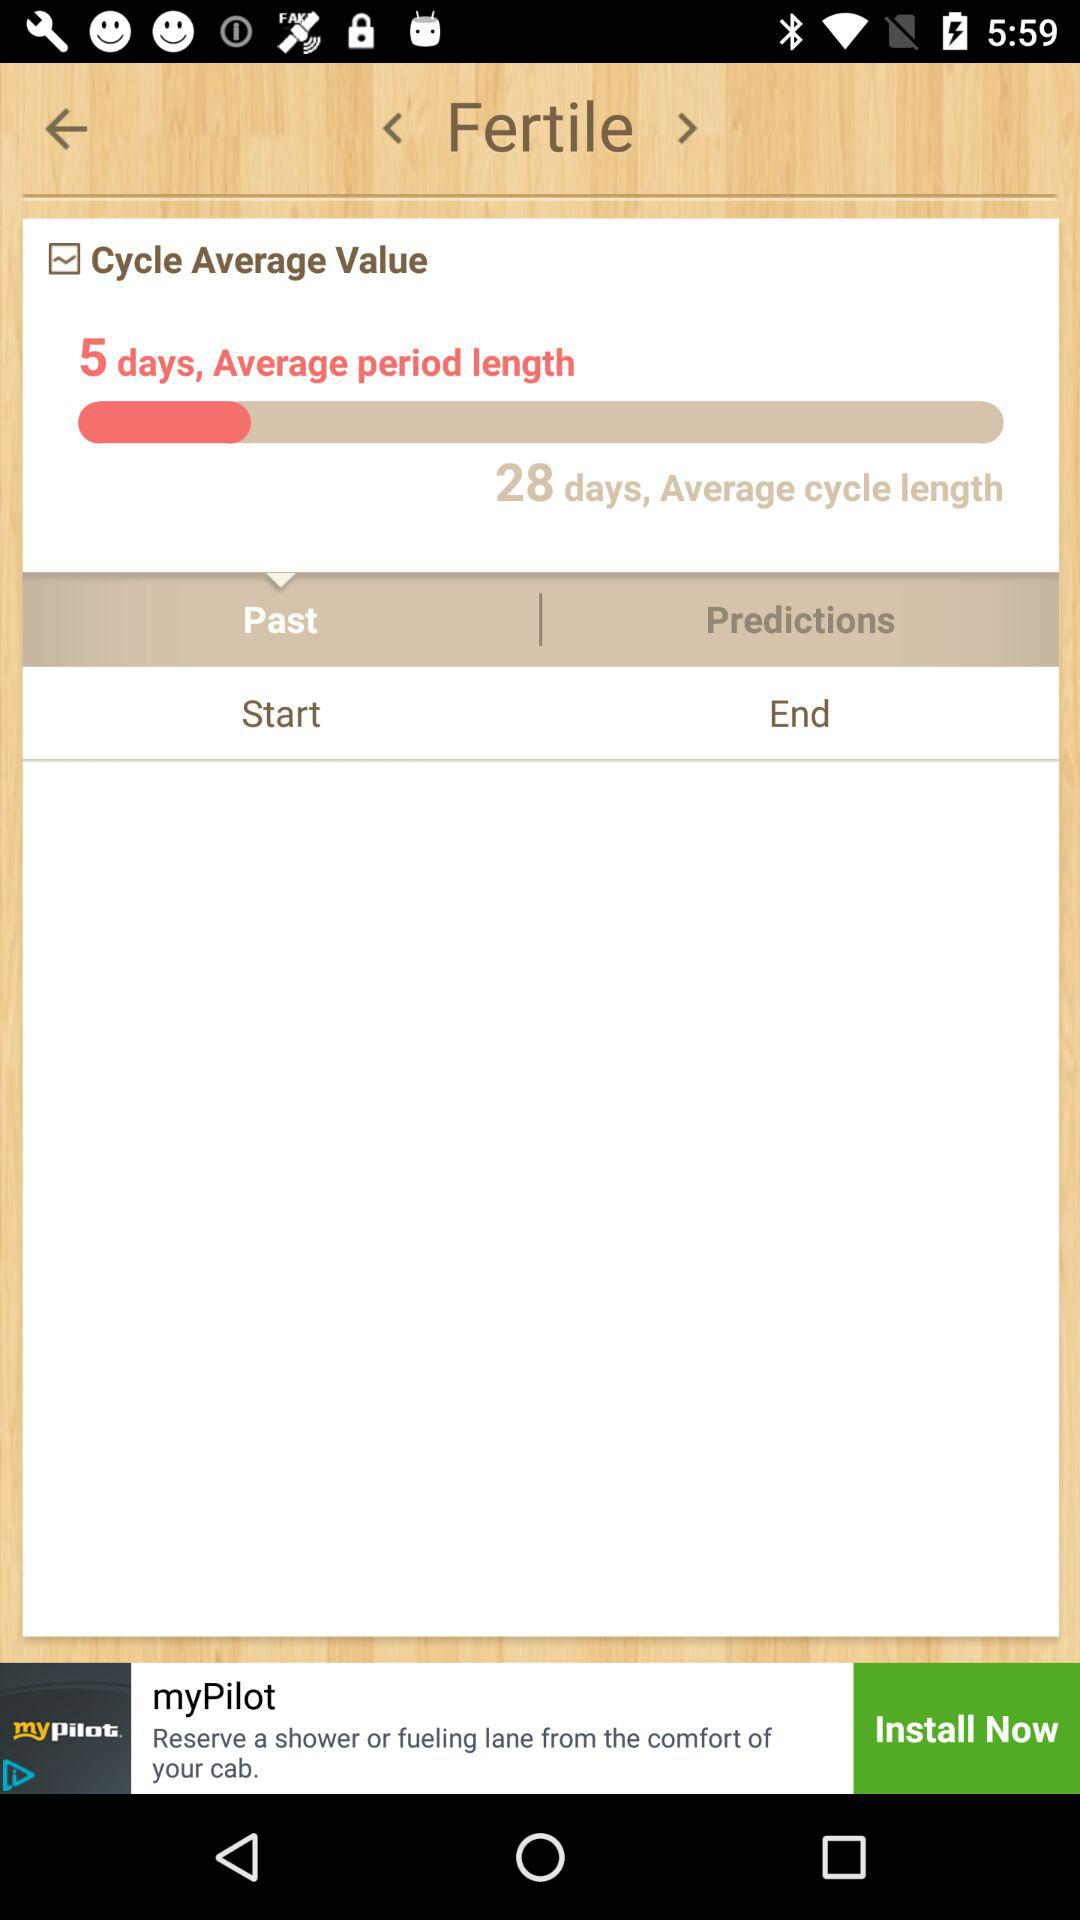What is the average cycle length? The average cycle length is 28 days. 